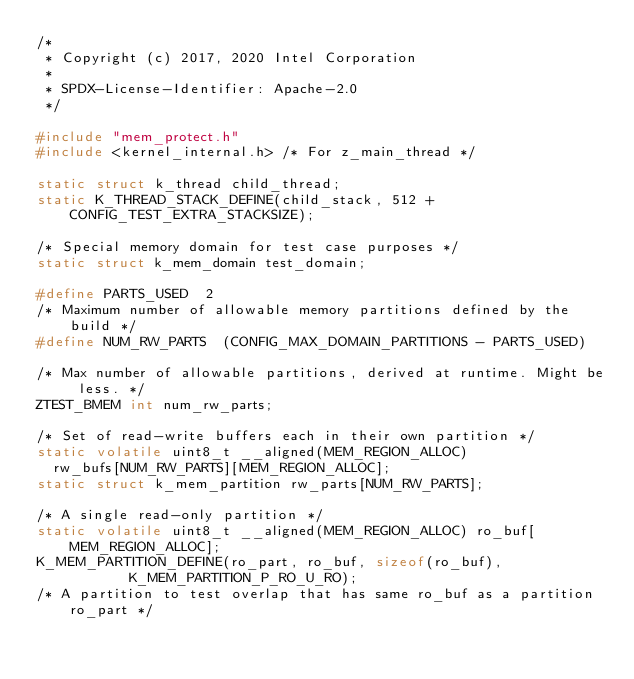<code> <loc_0><loc_0><loc_500><loc_500><_C_>/*
 * Copyright (c) 2017, 2020 Intel Corporation
 *
 * SPDX-License-Identifier: Apache-2.0
 */

#include "mem_protect.h"
#include <kernel_internal.h> /* For z_main_thread */

static struct k_thread child_thread;
static K_THREAD_STACK_DEFINE(child_stack, 512 + CONFIG_TEST_EXTRA_STACKSIZE);

/* Special memory domain for test case purposes */
static struct k_mem_domain test_domain;

#define PARTS_USED	2
/* Maximum number of allowable memory partitions defined by the build */
#define NUM_RW_PARTS	(CONFIG_MAX_DOMAIN_PARTITIONS - PARTS_USED)

/* Max number of allowable partitions, derived at runtime. Might be less. */
ZTEST_BMEM int num_rw_parts;

/* Set of read-write buffers each in their own partition */
static volatile uint8_t __aligned(MEM_REGION_ALLOC)
	rw_bufs[NUM_RW_PARTS][MEM_REGION_ALLOC];
static struct k_mem_partition rw_parts[NUM_RW_PARTS];

/* A single read-only partition */
static volatile uint8_t __aligned(MEM_REGION_ALLOC) ro_buf[MEM_REGION_ALLOC];
K_MEM_PARTITION_DEFINE(ro_part, ro_buf, sizeof(ro_buf),
		       K_MEM_PARTITION_P_RO_U_RO);
/* A partition to test overlap that has same ro_buf as a partition ro_part */</code> 